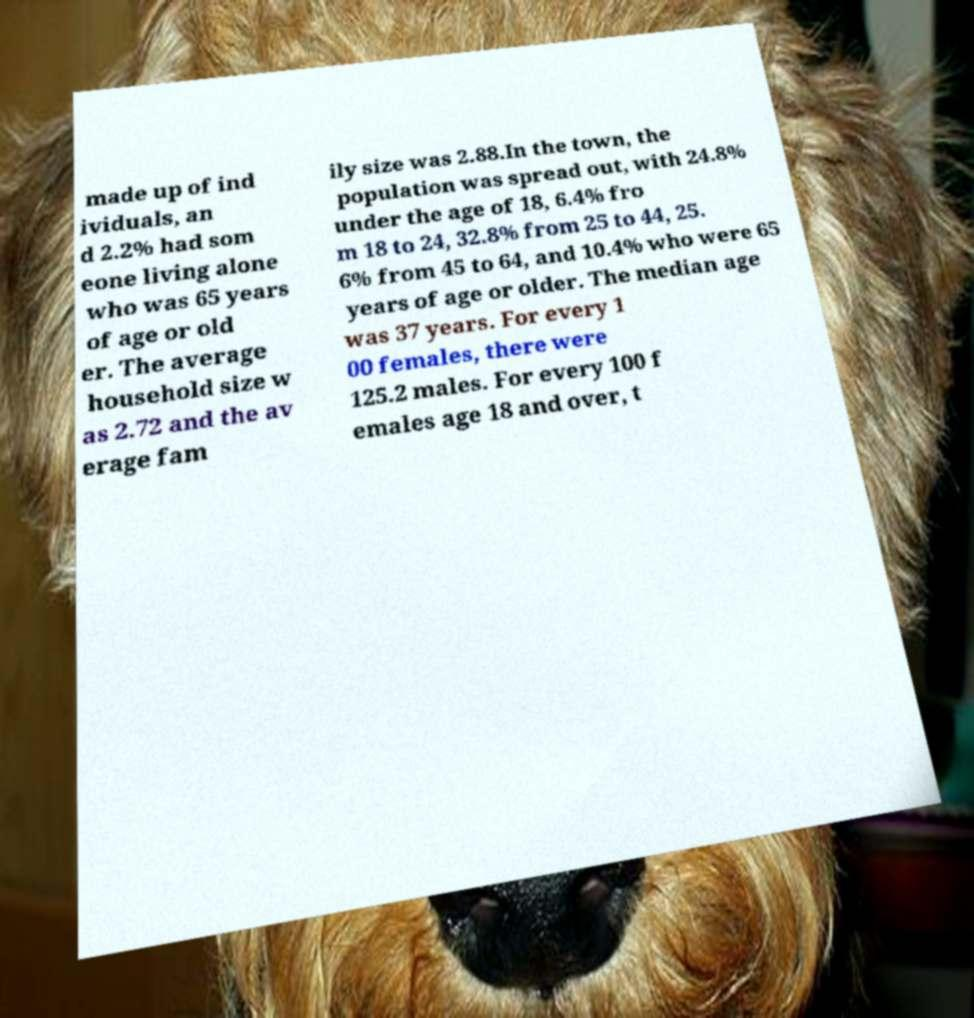Please read and relay the text visible in this image. What does it say? made up of ind ividuals, an d 2.2% had som eone living alone who was 65 years of age or old er. The average household size w as 2.72 and the av erage fam ily size was 2.88.In the town, the population was spread out, with 24.8% under the age of 18, 6.4% fro m 18 to 24, 32.8% from 25 to 44, 25. 6% from 45 to 64, and 10.4% who were 65 years of age or older. The median age was 37 years. For every 1 00 females, there were 125.2 males. For every 100 f emales age 18 and over, t 